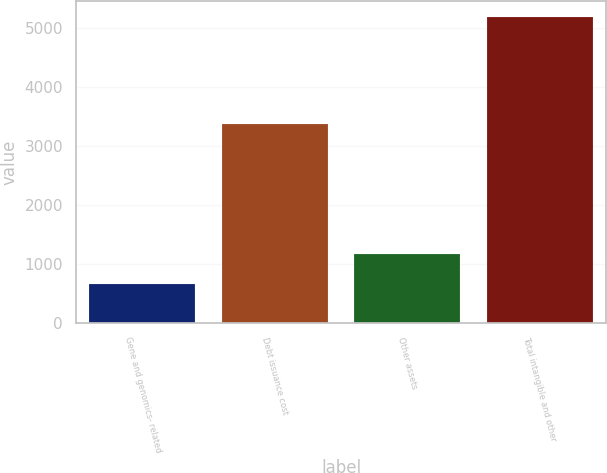Convert chart to OTSL. <chart><loc_0><loc_0><loc_500><loc_500><bar_chart><fcel>Gene and genomics- related<fcel>Debt issuance cost<fcel>Other assets<fcel>Total intangible and other<nl><fcel>651<fcel>3377<fcel>1167<fcel>5195<nl></chart> 